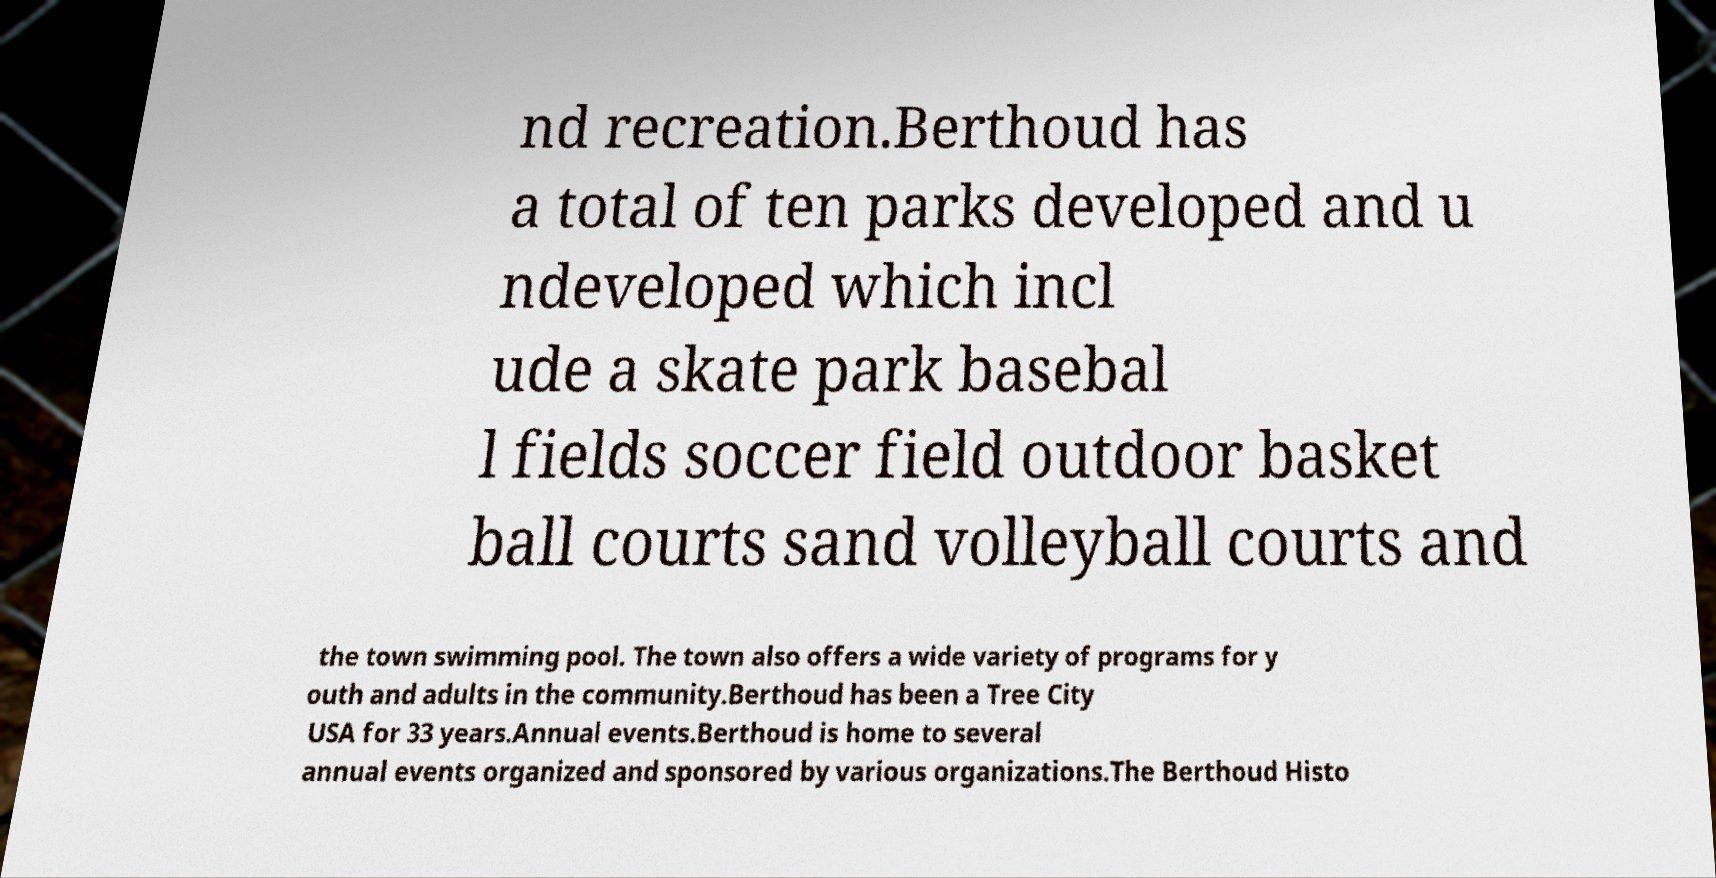There's text embedded in this image that I need extracted. Can you transcribe it verbatim? nd recreation.Berthoud has a total of ten parks developed and u ndeveloped which incl ude a skate park basebal l fields soccer field outdoor basket ball courts sand volleyball courts and the town swimming pool. The town also offers a wide variety of programs for y outh and adults in the community.Berthoud has been a Tree City USA for 33 years.Annual events.Berthoud is home to several annual events organized and sponsored by various organizations.The Berthoud Histo 